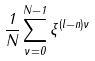<formula> <loc_0><loc_0><loc_500><loc_500>\frac { 1 } { N } \sum _ { \nu = 0 } ^ { N - 1 } \xi ^ { ( l - n ) \nu }</formula> 